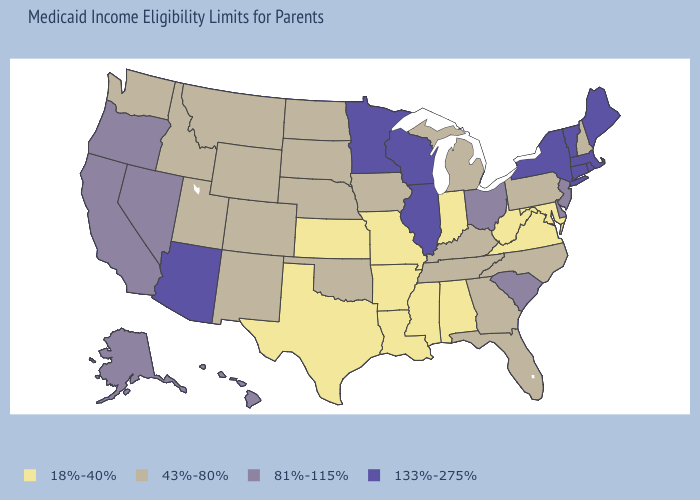Name the states that have a value in the range 81%-115%?
Be succinct. Alaska, California, Delaware, Hawaii, Nevada, New Jersey, Ohio, Oregon, South Carolina. Does Maine have a higher value than Arizona?
Give a very brief answer. No. What is the value of Ohio?
Answer briefly. 81%-115%. What is the value of Washington?
Short answer required. 43%-80%. Does Connecticut have the highest value in the Northeast?
Short answer required. Yes. What is the value of Nevada?
Short answer required. 81%-115%. Which states have the highest value in the USA?
Short answer required. Arizona, Connecticut, Illinois, Maine, Massachusetts, Minnesota, New York, Rhode Island, Vermont, Wisconsin. Which states have the lowest value in the USA?
Be succinct. Alabama, Arkansas, Indiana, Kansas, Louisiana, Maryland, Mississippi, Missouri, Texas, Virginia, West Virginia. Does New York have the highest value in the USA?
Quick response, please. Yes. Does Arizona have the same value as Minnesota?
Be succinct. Yes. What is the lowest value in the MidWest?
Short answer required. 18%-40%. Name the states that have a value in the range 133%-275%?
Answer briefly. Arizona, Connecticut, Illinois, Maine, Massachusetts, Minnesota, New York, Rhode Island, Vermont, Wisconsin. Is the legend a continuous bar?
Quick response, please. No. What is the value of South Carolina?
Give a very brief answer. 81%-115%. What is the value of Maine?
Quick response, please. 133%-275%. 